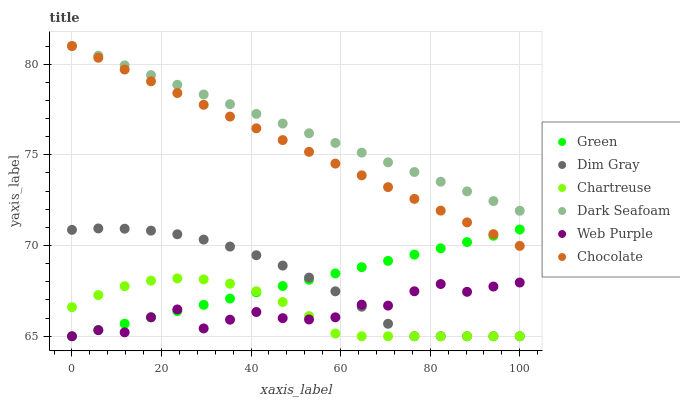Does Chartreuse have the minimum area under the curve?
Answer yes or no. Yes. Does Dark Seafoam have the maximum area under the curve?
Answer yes or no. Yes. Does Dark Seafoam have the minimum area under the curve?
Answer yes or no. No. Does Chartreuse have the maximum area under the curve?
Answer yes or no. No. Is Green the smoothest?
Answer yes or no. Yes. Is Web Purple the roughest?
Answer yes or no. Yes. Is Chartreuse the smoothest?
Answer yes or no. No. Is Chartreuse the roughest?
Answer yes or no. No. Does Dim Gray have the lowest value?
Answer yes or no. Yes. Does Dark Seafoam have the lowest value?
Answer yes or no. No. Does Chocolate have the highest value?
Answer yes or no. Yes. Does Chartreuse have the highest value?
Answer yes or no. No. Is Web Purple less than Dark Seafoam?
Answer yes or no. Yes. Is Dark Seafoam greater than Green?
Answer yes or no. Yes. Does Chartreuse intersect Web Purple?
Answer yes or no. Yes. Is Chartreuse less than Web Purple?
Answer yes or no. No. Is Chartreuse greater than Web Purple?
Answer yes or no. No. Does Web Purple intersect Dark Seafoam?
Answer yes or no. No. 